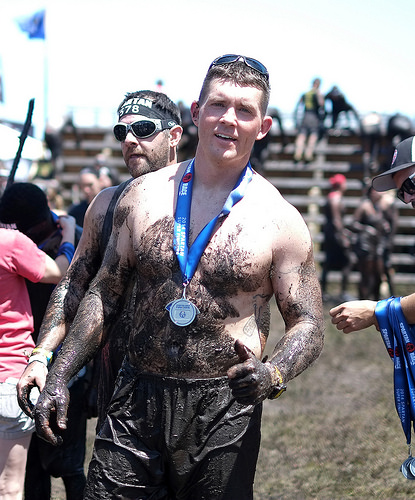<image>
Is the medal on the man? No. The medal is not positioned on the man. They may be near each other, but the medal is not supported by or resting on top of the man. Where is the medal in relation to the man? Is it on the man? No. The medal is not positioned on the man. They may be near each other, but the medal is not supported by or resting on top of the man. 